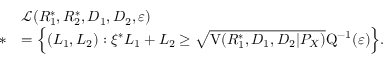Convert formula to latex. <formula><loc_0><loc_0><loc_500><loc_500>\begin{array} { r l } & { \mathcal { L } ( R _ { 1 } ^ { * } , R _ { 2 } ^ { * } , D _ { 1 } , D _ { 2 } , \varepsilon ) } \\ { * } & { = \left \{ ( L _ { 1 } , L _ { 2 } ) \colon \xi ^ { * } L _ { 1 } + L _ { 2 } \geq \sqrt { V ( R _ { 1 } ^ { * } , D _ { 1 } , D _ { 2 } | P _ { X } ) } Q ^ { - 1 } ( \varepsilon ) \right \} . } \end{array}</formula> 